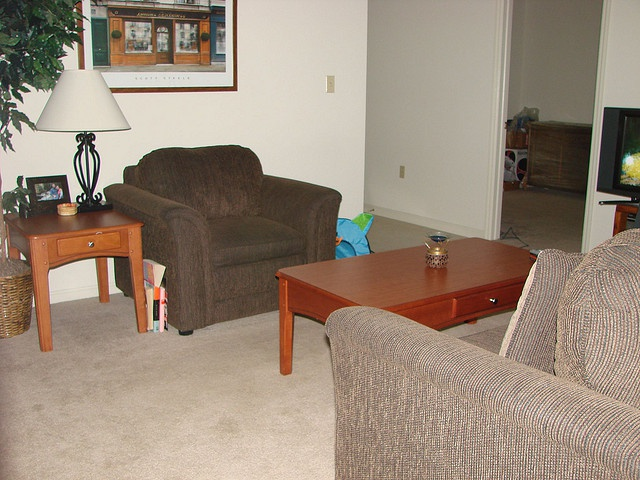Describe the objects in this image and their specific colors. I can see couch in black, darkgray, gray, and tan tones, chair in black, maroon, and gray tones, dining table in black, maroon, and brown tones, potted plant in black, gray, lightgray, and darkgreen tones, and tv in black, olive, and gray tones in this image. 